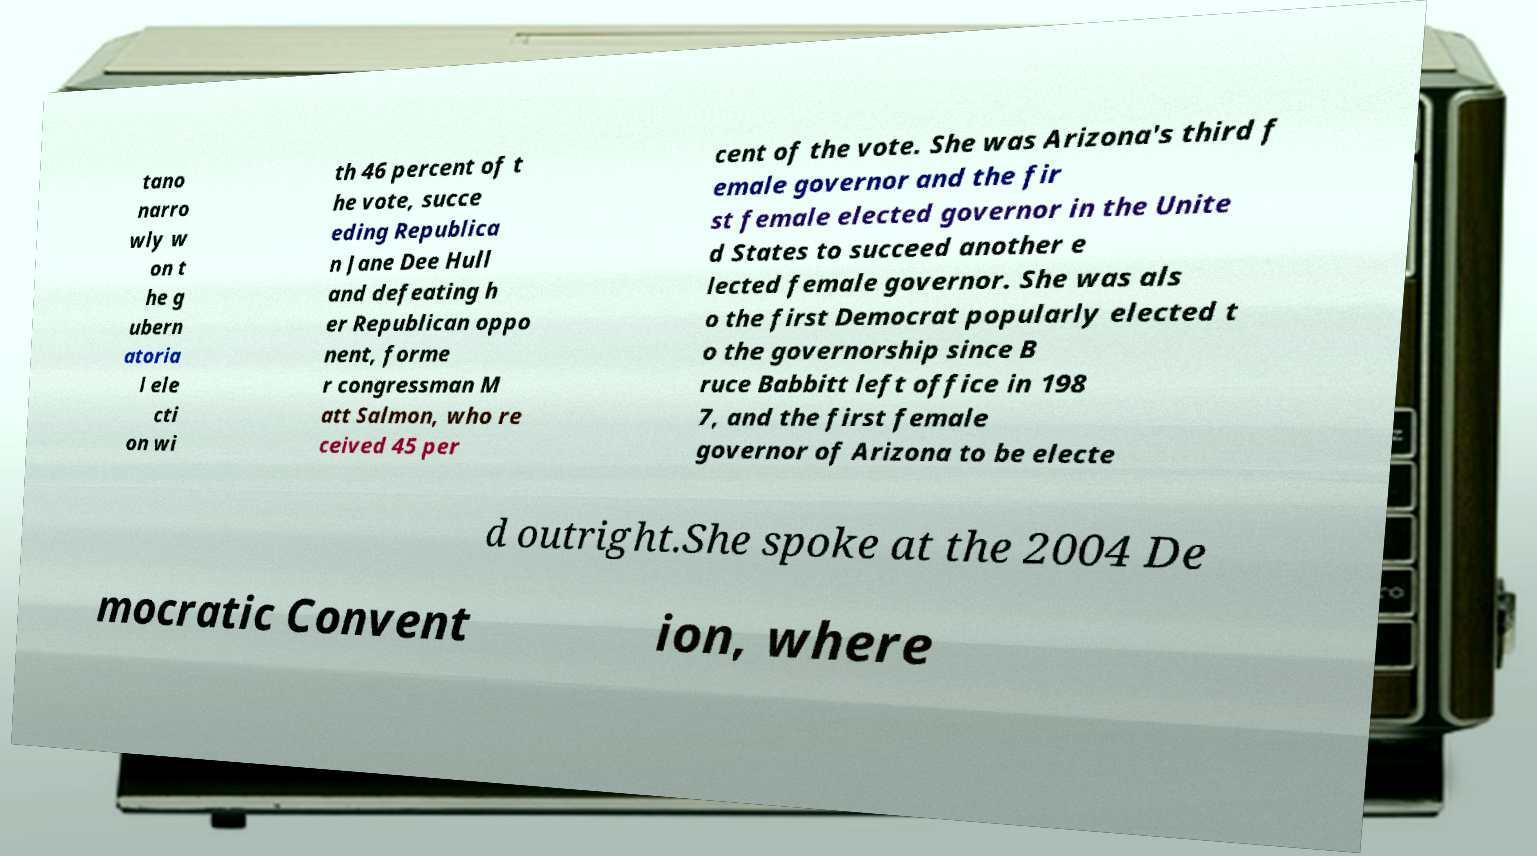Can you read and provide the text displayed in the image?This photo seems to have some interesting text. Can you extract and type it out for me? tano narro wly w on t he g ubern atoria l ele cti on wi th 46 percent of t he vote, succe eding Republica n Jane Dee Hull and defeating h er Republican oppo nent, forme r congressman M att Salmon, who re ceived 45 per cent of the vote. She was Arizona's third f emale governor and the fir st female elected governor in the Unite d States to succeed another e lected female governor. She was als o the first Democrat popularly elected t o the governorship since B ruce Babbitt left office in 198 7, and the first female governor of Arizona to be electe d outright.She spoke at the 2004 De mocratic Convent ion, where 